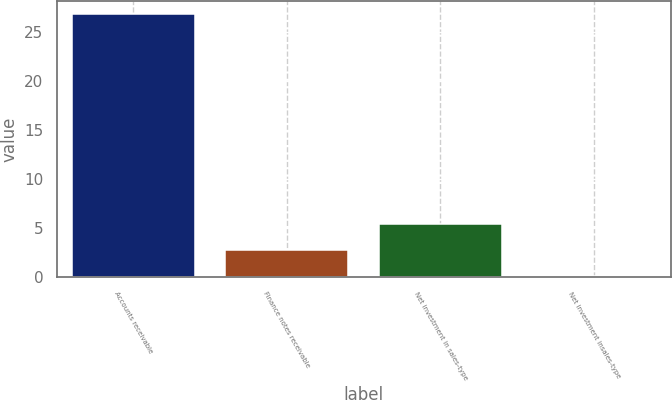Convert chart to OTSL. <chart><loc_0><loc_0><loc_500><loc_500><bar_chart><fcel>Accounts receivable<fcel>Finance notes receivable<fcel>Net investment in sales-type<fcel>Net investment insales-type<nl><fcel>26.8<fcel>2.77<fcel>5.44<fcel>0.1<nl></chart> 